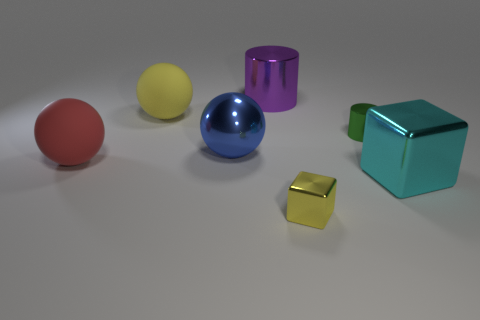Are there any other things that are the same material as the tiny cube?
Your response must be concise. Yes. What number of red things are either small cylinders or metal cylinders?
Keep it short and to the point. 0. What is the material of the cylinder on the right side of the yellow metallic block?
Offer a terse response. Metal. Is the number of small purple rubber cylinders greater than the number of big yellow things?
Give a very brief answer. No. There is a metal thing that is behind the big yellow ball; does it have the same shape as the big blue metallic object?
Offer a very short reply. No. What number of large things are both on the left side of the tiny yellow object and right of the tiny green metallic thing?
Your answer should be compact. 0. What number of yellow metal things are the same shape as the green metallic thing?
Make the answer very short. 0. There is a big metal object that is left of the cylinder that is to the left of the green metal cylinder; what is its color?
Provide a succinct answer. Blue. Do the big yellow rubber object and the large metal thing that is behind the yellow rubber thing have the same shape?
Offer a terse response. No. There is a tiny cube that is in front of the cylinder in front of the big shiny object behind the yellow matte object; what is it made of?
Offer a terse response. Metal. 